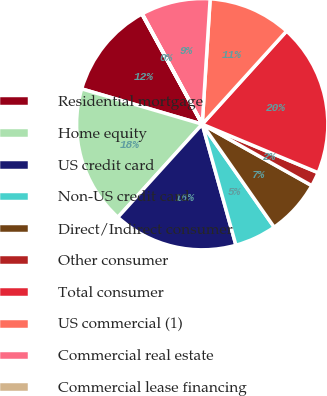Convert chart to OTSL. <chart><loc_0><loc_0><loc_500><loc_500><pie_chart><fcel>Residential mortgage<fcel>Home equity<fcel>US credit card<fcel>Non-US credit card<fcel>Direct/Indirect consumer<fcel>Other consumer<fcel>Total consumer<fcel>US commercial (1)<fcel>Commercial real estate<fcel>Commercial lease financing<nl><fcel>12.49%<fcel>17.82%<fcel>16.04%<fcel>5.38%<fcel>7.16%<fcel>1.83%<fcel>19.59%<fcel>10.71%<fcel>8.93%<fcel>0.05%<nl></chart> 